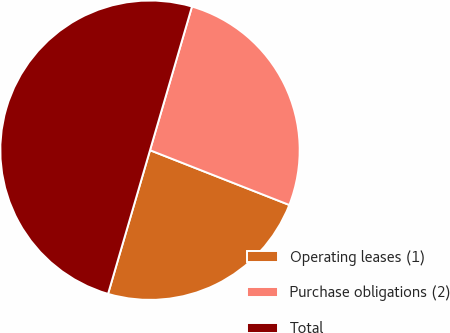Convert chart. <chart><loc_0><loc_0><loc_500><loc_500><pie_chart><fcel>Operating leases (1)<fcel>Purchase obligations (2)<fcel>Total<nl><fcel>23.56%<fcel>26.44%<fcel>50.0%<nl></chart> 